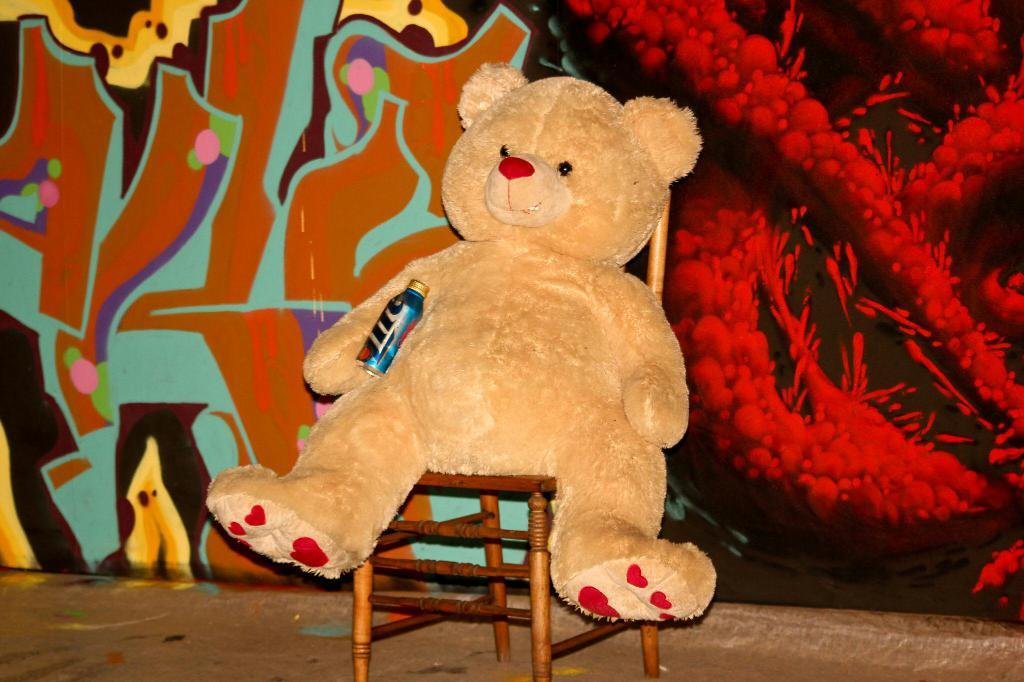What is hanging on the wall in the image? There is a painting on the wall. What object is sitting on the chair in the image? A teddy is sitting on a chair. What is the teddy holding in the image? The teddy is holding a bottle. Where is the park located in the image? There is no park present in the image. What type of lunch is the teddy eating in the image? The teddy is not eating lunch in the image; it is holding a bottle. 